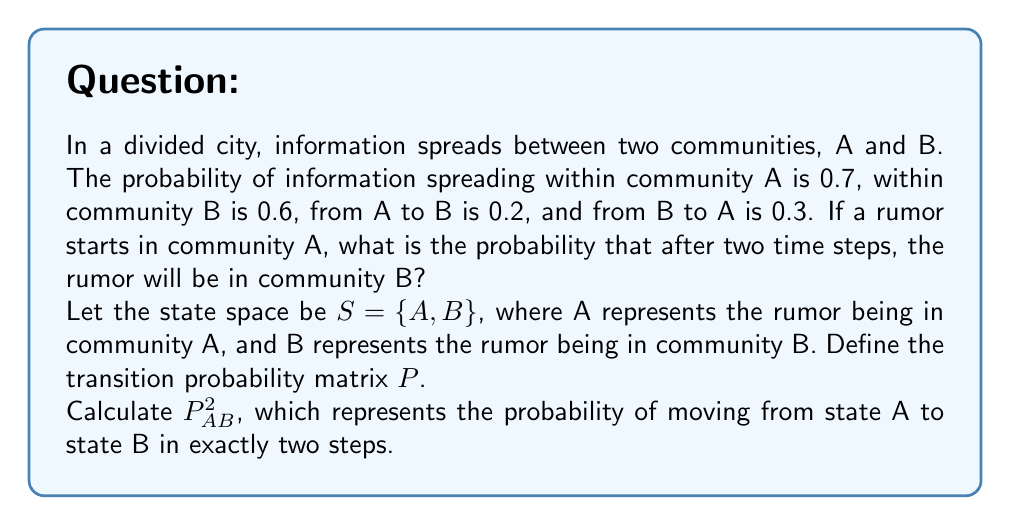What is the answer to this math problem? Let's approach this step-by-step:

1) First, we need to define the transition probability matrix $P$. Given the probabilities in the question:

   $$P = \begin{bmatrix}
   0.7 & 0.3 \\
   0.2 & 0.8
   \end{bmatrix}$$

   Where $P_{ij}$ represents the probability of moving from state $i$ to state $j$ in one step.

2) To find the probability of moving from A to B in exactly two steps, we need to calculate $P^2$:

   $$P^2 = P \times P = \begin{bmatrix}
   0.7 & 0.3 \\
   0.2 & 0.8
   \end{bmatrix} \times \begin{bmatrix}
   0.7 & 0.3 \\
   0.2 & 0.8
   \end{bmatrix}$$

3) Let's perform the matrix multiplication:

   $$P^2 = \begin{bmatrix}
   (0.7 \times 0.7 + 0.3 \times 0.2) & (0.7 \times 0.3 + 0.3 \times 0.8) \\
   (0.2 \times 0.7 + 0.8 \times 0.2) & (0.2 \times 0.3 + 0.8 \times 0.8)
   \end{bmatrix}$$

4) Calculating each element:

   $$P^2 = \begin{bmatrix}
   0.55 & 0.45 \\
   0.30 & 0.70
   \end{bmatrix}$$

5) The probability we're looking for is $P^2_{AB}$, which is the element in the first row, second column of $P^2$. This represents the probability of moving from state A to state B in exactly two steps.

Therefore, $P^2_{AB} = 0.45$
Answer: 0.45 